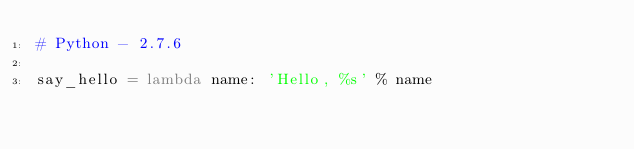<code> <loc_0><loc_0><loc_500><loc_500><_Python_># Python - 2.7.6

say_hello = lambda name: 'Hello, %s' % name
</code> 